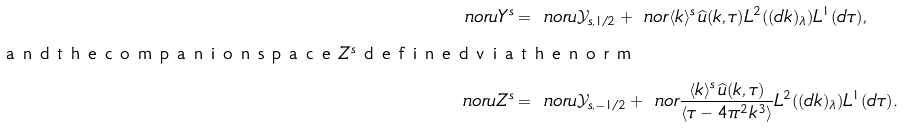Convert formula to latex. <formula><loc_0><loc_0><loc_500><loc_500>\ n o r { u } { Y ^ { s } } & = \ n o r { u } { \mathcal { Y } _ { s , 1 / 2 } } + \ n o r { \langle k \rangle ^ { s } \, \widehat { u } ( k , \tau ) } { L ^ { 2 } ( ( d k ) _ { \lambda } ) L ^ { 1 } ( d \tau ) } , \\ \intertext { a n d t h e c o m p a n i o n s p a c e $ Z ^ { s } $ d e f i n e d v i a t h e n o r m } \ n o r { u } { Z ^ { s } } & = \ n o r { u } { \mathcal { Y } _ { s , - 1 / 2 } } + \ n o r { \frac { \langle k \rangle ^ { s } \, \widehat { u } ( k , \tau ) } { \langle \tau - 4 \pi ^ { 2 } k ^ { 3 } \rangle } } { L ^ { 2 } ( ( d k ) _ { \lambda } ) L ^ { 1 } ( d \tau ) } .</formula> 